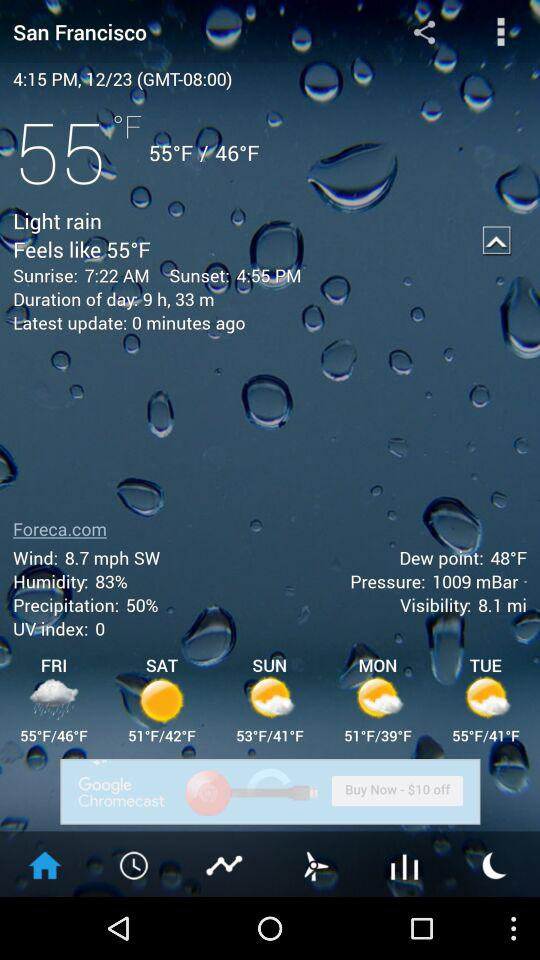What is the temperature? The temperature is 55 °F. 